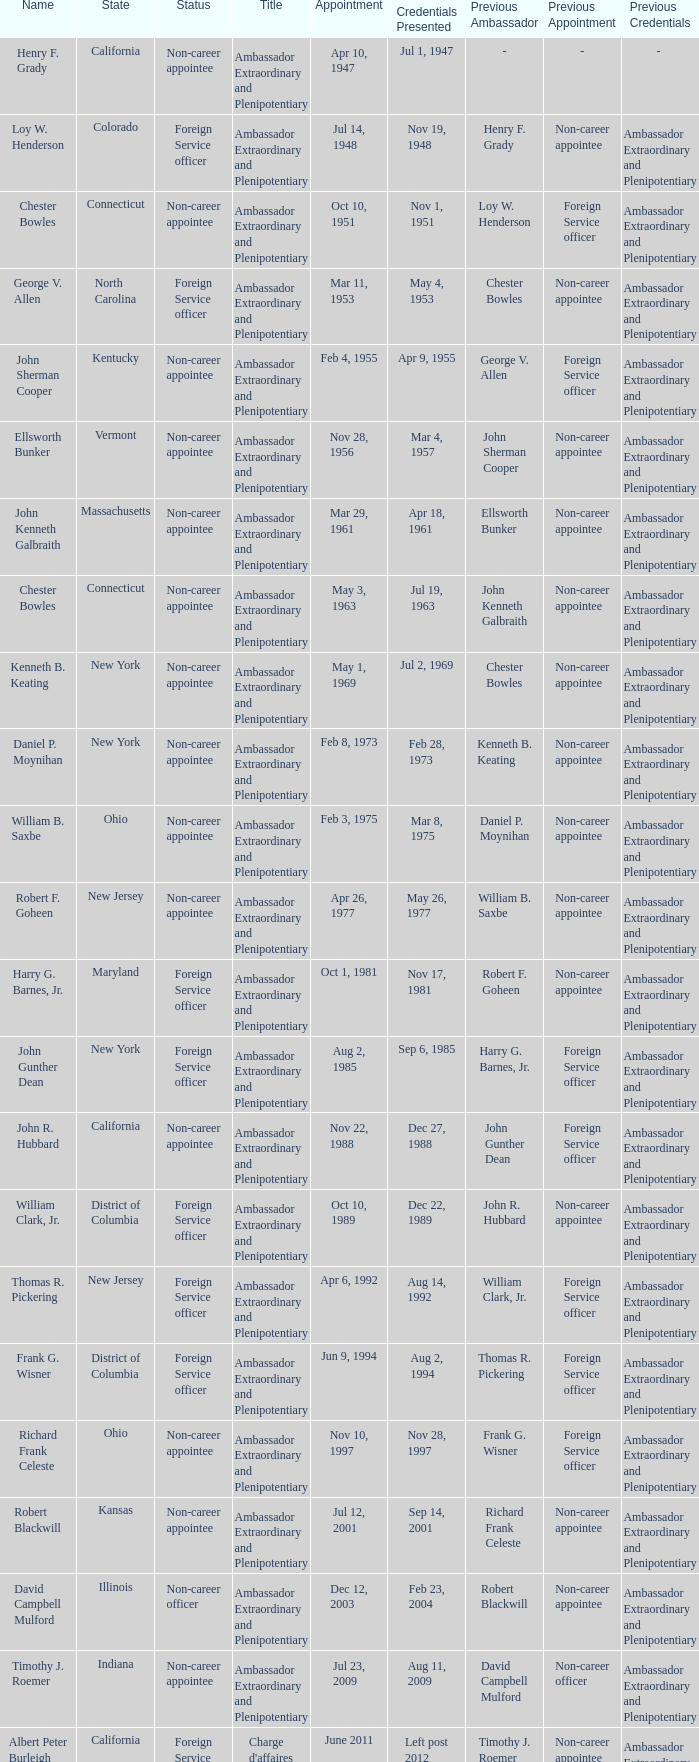What position or designation does david campbell mulford have? Ambassador Extraordinary and Plenipotentiary. 